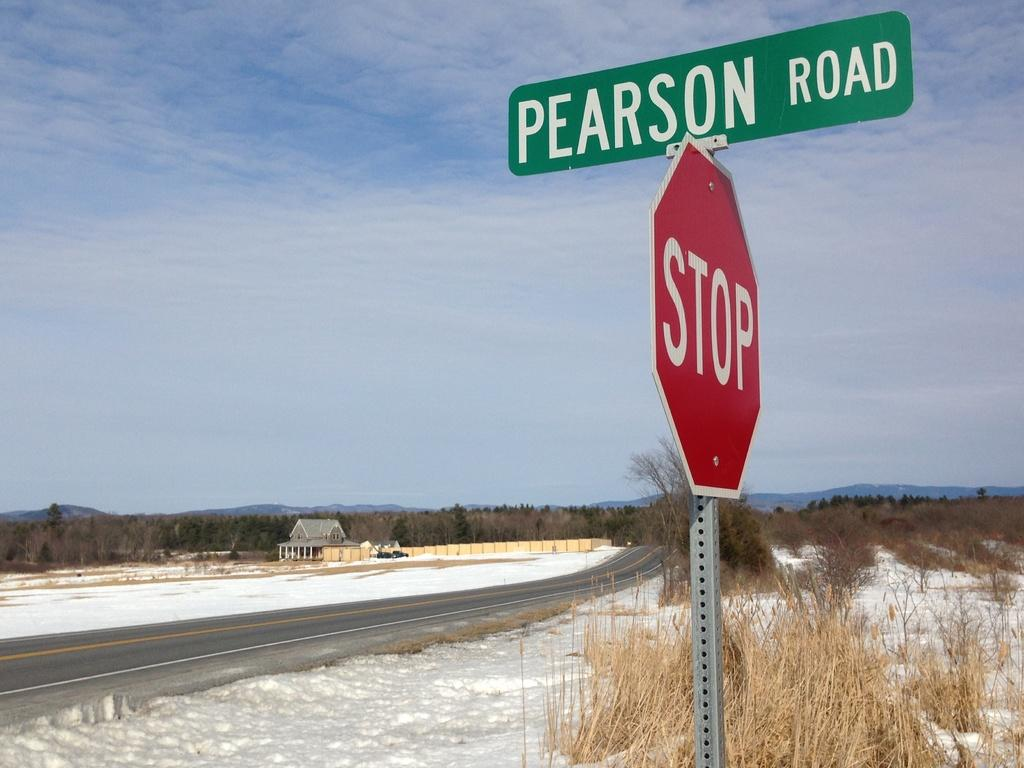<image>
Provide a brief description of the given image. A red and white stop sign with a green and white street sign on top of it that reads pearson road. 